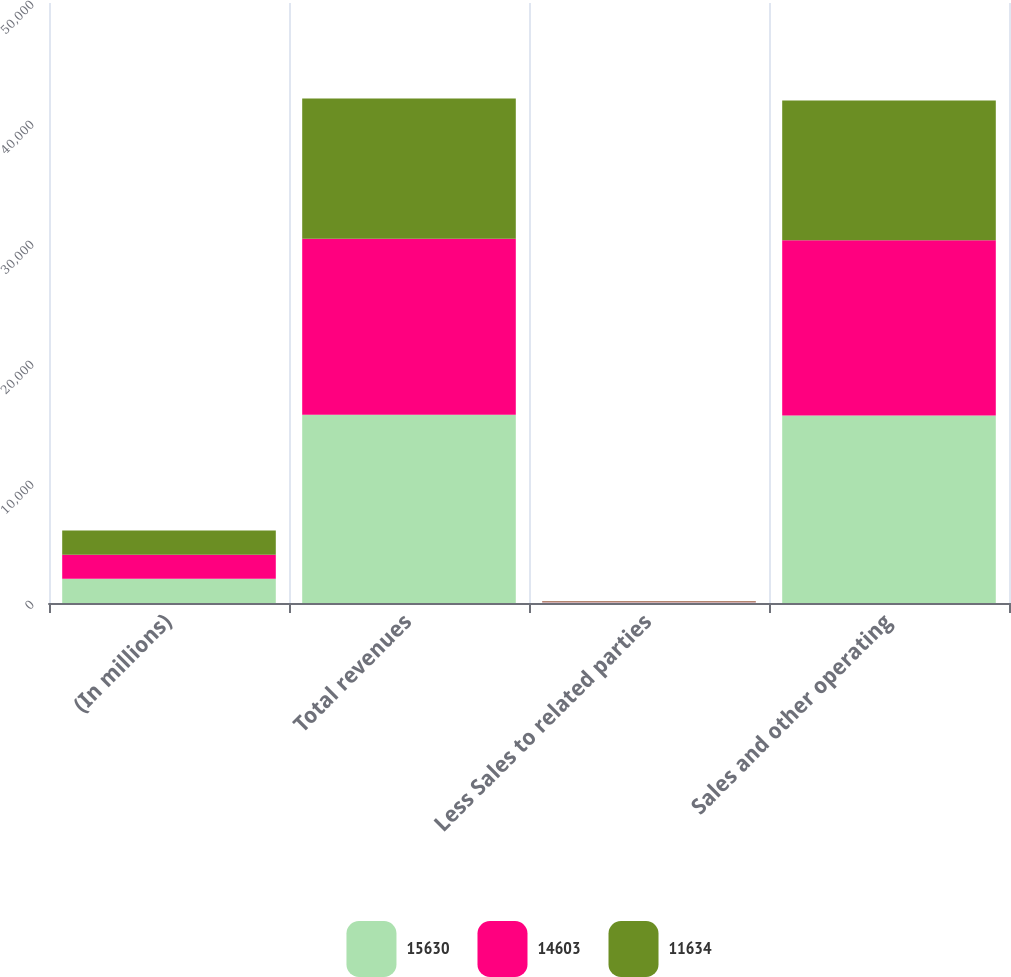<chart> <loc_0><loc_0><loc_500><loc_500><stacked_bar_chart><ecel><fcel>(In millions)<fcel>Total revenues<fcel>Less Sales to related parties<fcel>Sales and other operating<nl><fcel>15630<fcel>2012<fcel>15688<fcel>58<fcel>15630<nl><fcel>14603<fcel>2011<fcel>14663<fcel>60<fcel>14603<nl><fcel>11634<fcel>2010<fcel>11690<fcel>56<fcel>11634<nl></chart> 